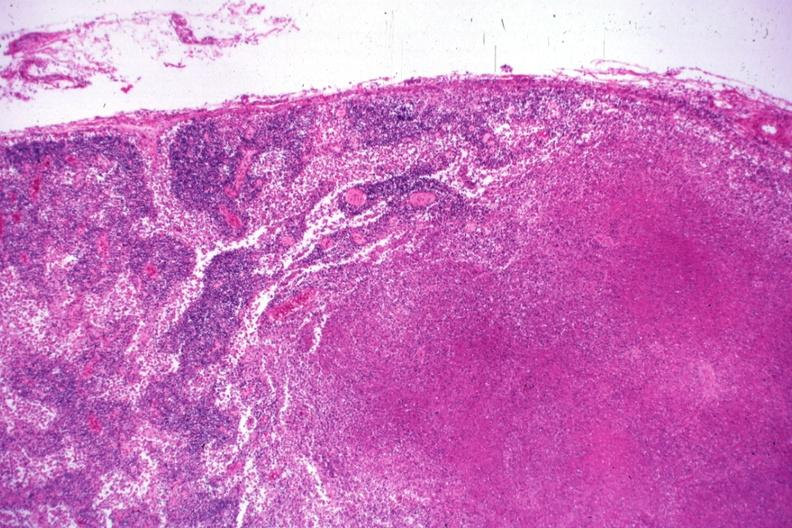does this image show low typical necrotizing lesion?
Answer the question using a single word or phrase. Yes 